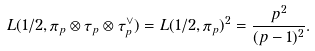<formula> <loc_0><loc_0><loc_500><loc_500>L ( 1 / 2 , \pi _ { p } \otimes \tau _ { p } \otimes \tau _ { p } ^ { \vee } ) = L ( 1 / 2 , \pi _ { p } ) ^ { 2 } = \frac { p ^ { 2 } } { ( p - 1 ) ^ { 2 } } .</formula> 